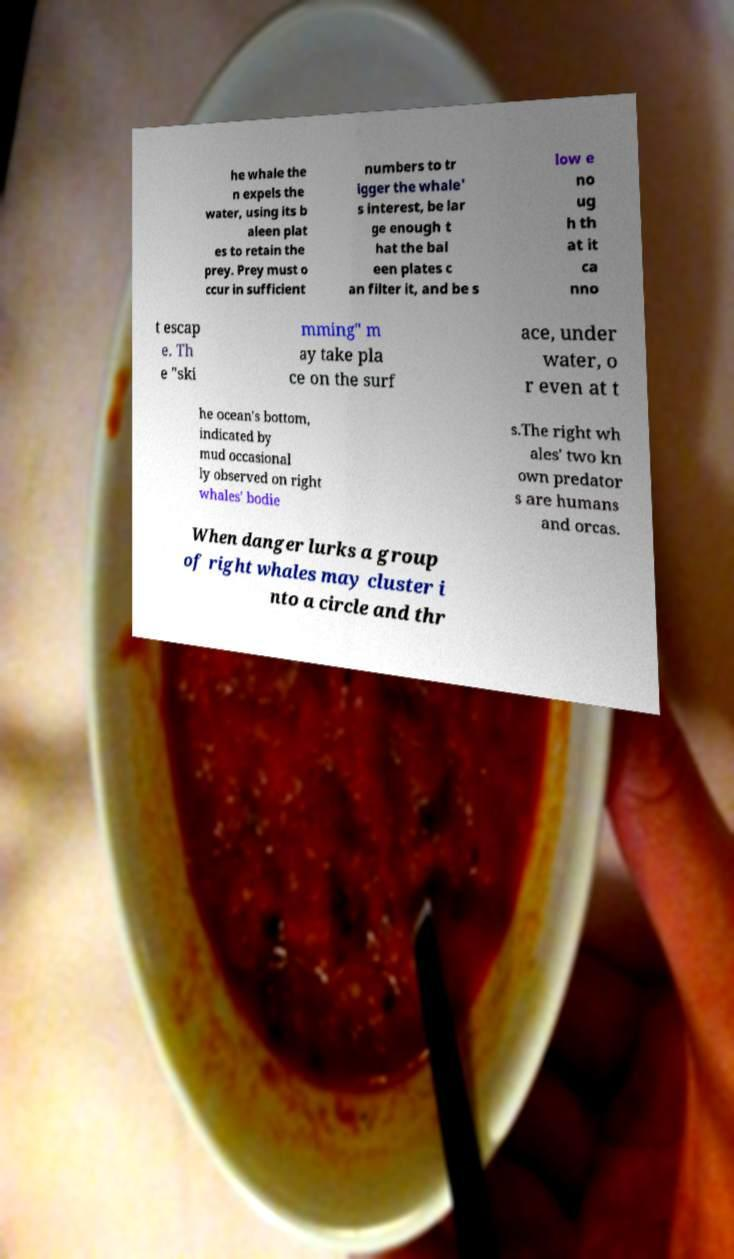Can you read and provide the text displayed in the image?This photo seems to have some interesting text. Can you extract and type it out for me? he whale the n expels the water, using its b aleen plat es to retain the prey. Prey must o ccur in sufficient numbers to tr igger the whale' s interest, be lar ge enough t hat the bal een plates c an filter it, and be s low e no ug h th at it ca nno t escap e. Th e "ski mming" m ay take pla ce on the surf ace, under water, o r even at t he ocean's bottom, indicated by mud occasional ly observed on right whales' bodie s.The right wh ales' two kn own predator s are humans and orcas. When danger lurks a group of right whales may cluster i nto a circle and thr 